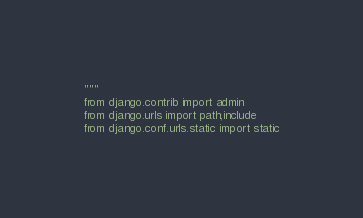<code> <loc_0><loc_0><loc_500><loc_500><_Python_>"""
from django.contrib import admin
from django.urls import path,include
from django.conf.urls.static import static</code> 